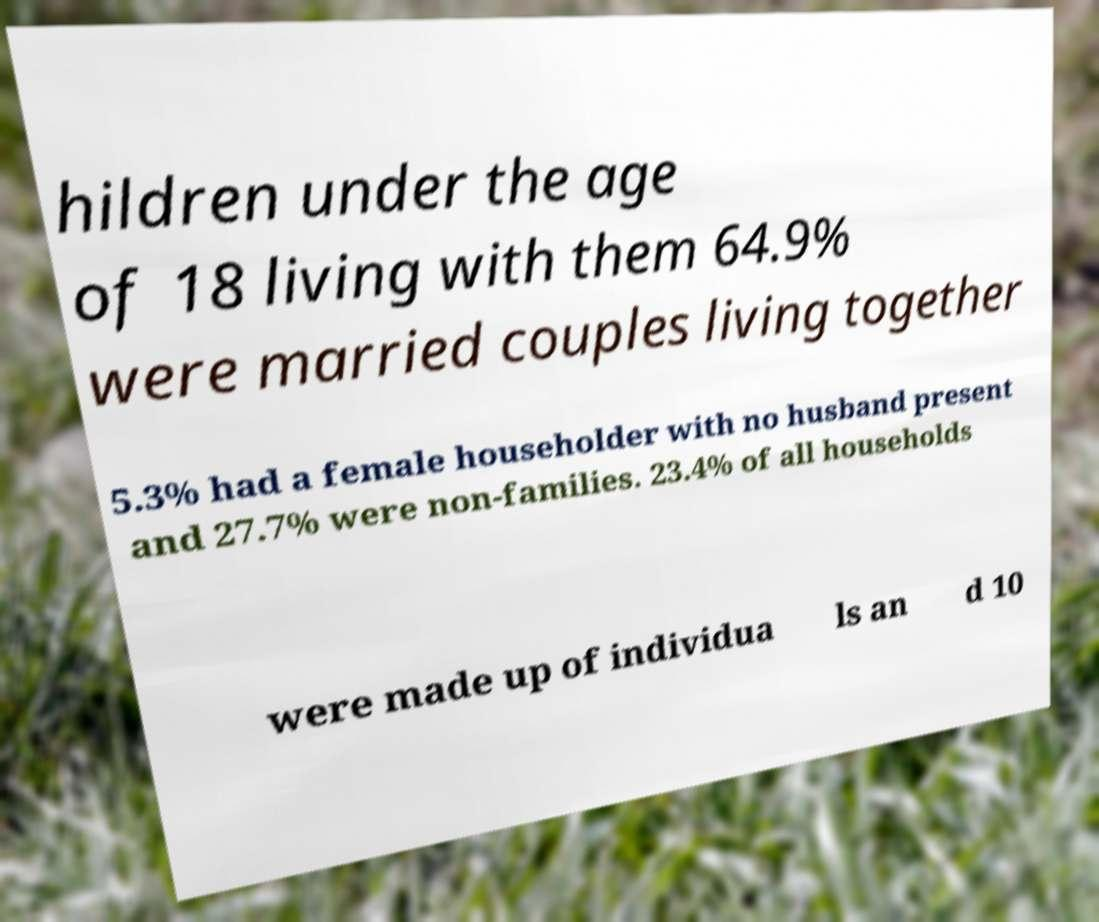There's text embedded in this image that I need extracted. Can you transcribe it verbatim? hildren under the age of 18 living with them 64.9% were married couples living together 5.3% had a female householder with no husband present and 27.7% were non-families. 23.4% of all households were made up of individua ls an d 10 